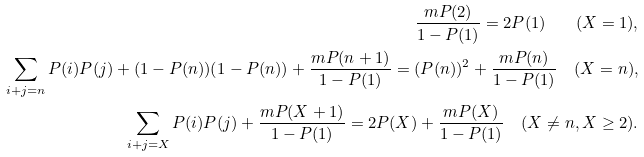<formula> <loc_0><loc_0><loc_500><loc_500>\frac { m P ( 2 ) } { 1 - P ( 1 ) } = 2 P ( 1 ) \quad ( X = 1 ) , \\ \sum _ { i + j = n } P ( i ) P ( j ) + ( 1 - P ( n ) ) ( 1 - P ( n ) ) + \frac { m P ( n + 1 ) } { 1 - P ( 1 ) } = ( P ( n ) ) ^ { 2 } + \frac { m P ( n ) } { 1 - P ( 1 ) } \quad ( X = n ) , \\ \sum _ { i + j = X } P ( i ) P ( j ) + \frac { m P ( X + 1 ) } { 1 - P ( 1 ) } = 2 P ( X ) + \frac { m P ( X ) } { 1 - P ( 1 ) } \quad ( X \ne n , X \geq 2 ) . \\</formula> 